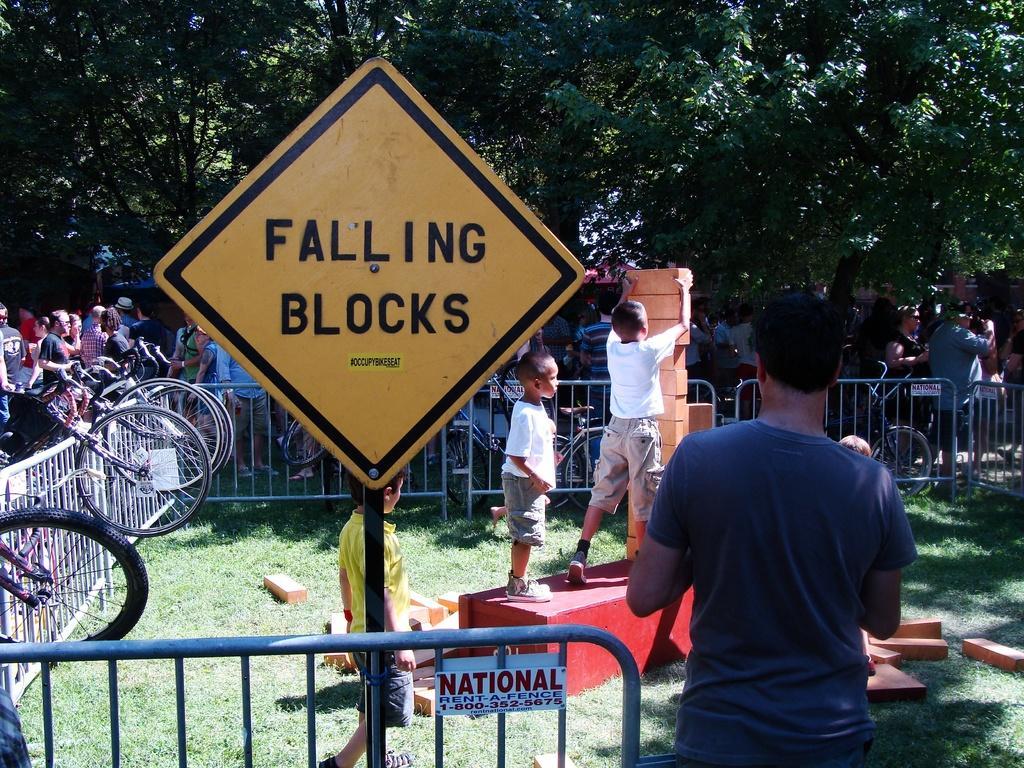Please provide a concise description of this image. In the foreground of the picture there are people, bricks, railing, bicycle, grass, board and other objects. In the background there are cars and trees. 